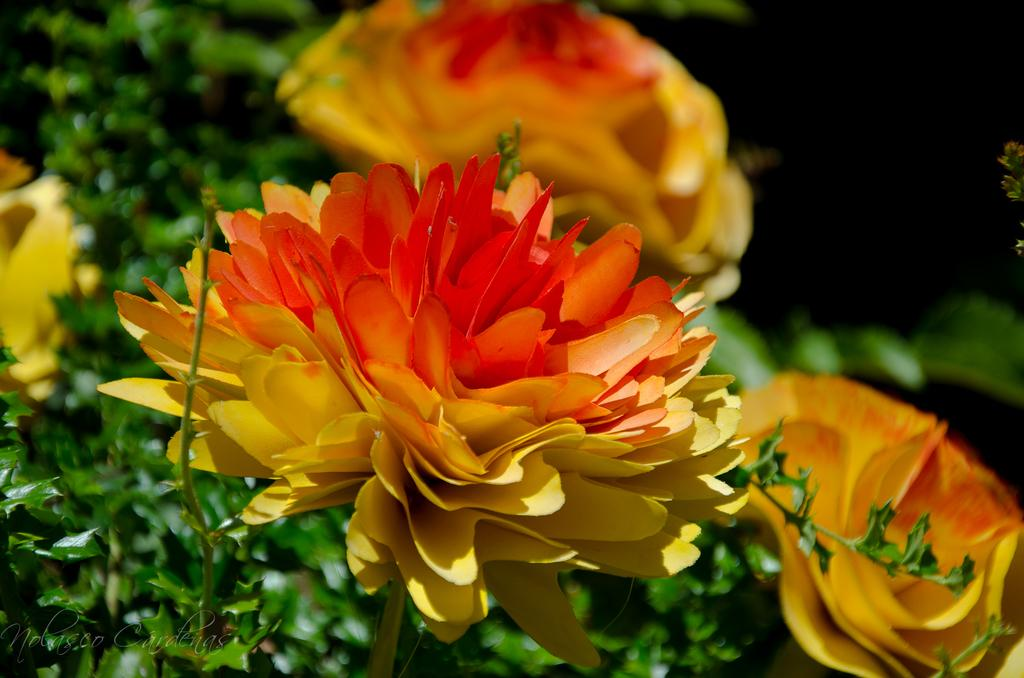What type of living organisms can be seen in the image? There are flowers and plants visible in the image. Where is the text located in the image? The text is in the bottom left corner of the image. What is the condition of the top right corner of the image? The top right corner of the image is dark. What type of advice can be seen on the face of the plant in the image? There is no face or advice present in the image; it features flowers and plants with text in the bottom left corner. 